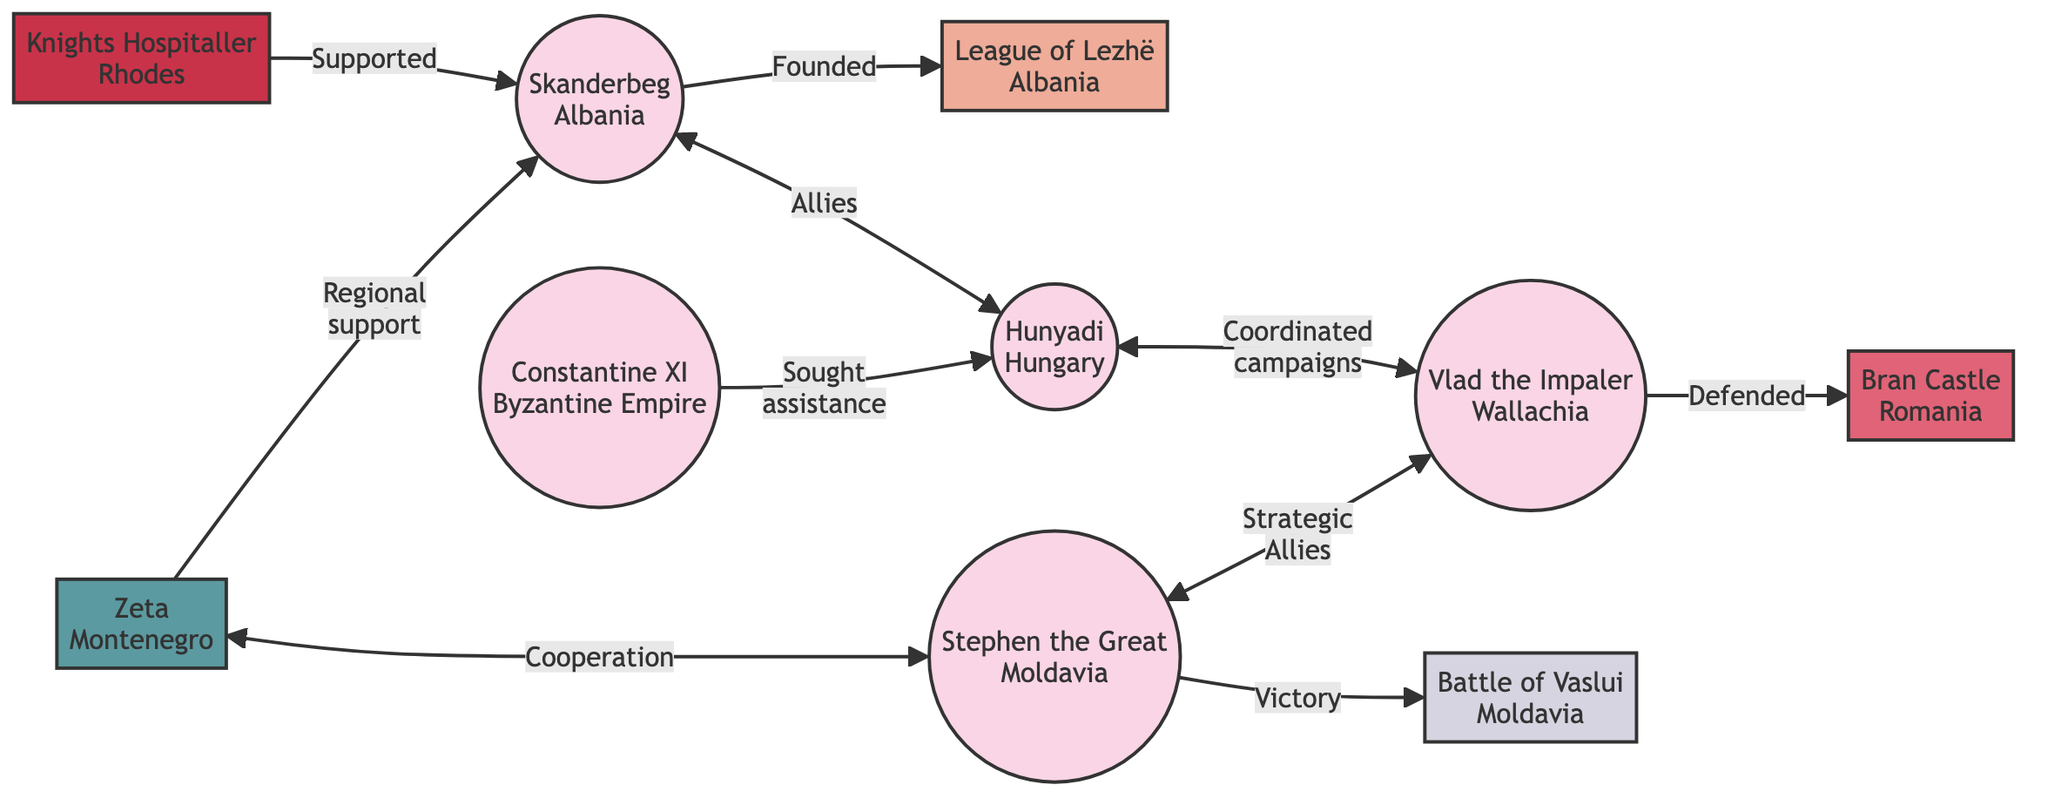What is the central figure in the resistance movements? The diagram highlights Skanderbeg as the leader associated with multiple connections to other nodes, illustrating his central role in the resistance movements against the Ottoman advance in South Europe.
Answer: Skanderbeg How many leaders are depicted in the diagram? By counting the nodes that are categorized as "Leader," which include Skanderbeg, Hunyadi, Vlad the Impaler, Constantine XI, and Stephen the Great, we find that there are a total of five leader nodes.
Answer: 5 What relationship exists between Hunyadi and Vlad the Impaler? The diagram shows a direct connection where Hunyadi coordinated campaigns with Vlad the Impaler, indicating a collaborative effort between them against the Ottomans.
Answer: Coordinated campaigns Which region supported Skanderbeg's efforts? Zeta, identified as a region in Montenegro, is linked with Skanderbeg in the diagram, indicating regional support for his resistance efforts against the Ottomans.
Answer: Zeta What significant event is associated with Stephen the Great? The Battle of Vaslui is directly connected to Stephen the Great, illustrating a key victory that he achieved against the Ottomans, marking a significant moment in the resistance movements.
Answer: Battle of Vaslui Which coalition did Skanderbeg establish? The diagram connects Skanderbeg directly to the League of Lezhë, which he founded as a coalition for resistance against the Ottoman advance, reflecting unity among various factions.
Answer: League of Lezhë Which leader sought assistance from Hunyadi? The diagram indicates that Constantine XI reached out for help from Hunyadi, showcasing the interconnected nature of resistance leaders in their efforts against the Ottoman forces.
Answer: Constantine XI What support did the Knights Hospitaller provide? The Knights Hospitaller are linked to Skanderbeg as providing resources, demonstrating their role in supporting the resistance movements through material means.
Answer: Supported with resources 